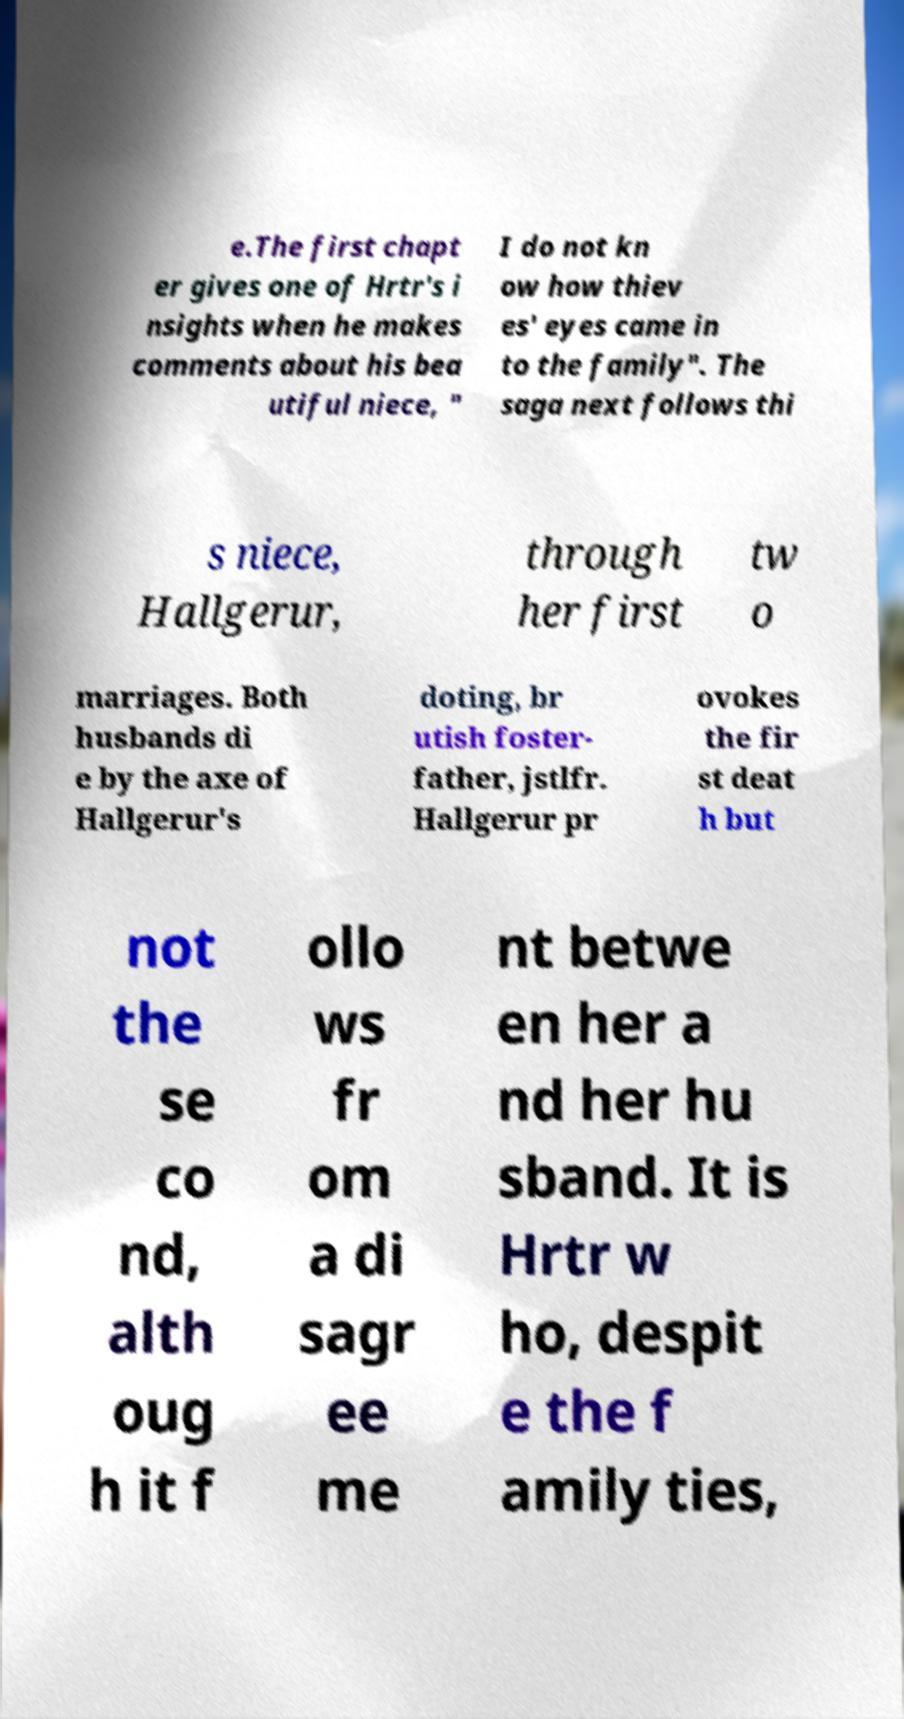There's text embedded in this image that I need extracted. Can you transcribe it verbatim? e.The first chapt er gives one of Hrtr's i nsights when he makes comments about his bea utiful niece, " I do not kn ow how thiev es' eyes came in to the family". The saga next follows thi s niece, Hallgerur, through her first tw o marriages. Both husbands di e by the axe of Hallgerur's doting, br utish foster- father, jstlfr. Hallgerur pr ovokes the fir st deat h but not the se co nd, alth oug h it f ollo ws fr om a di sagr ee me nt betwe en her a nd her hu sband. It is Hrtr w ho, despit e the f amily ties, 